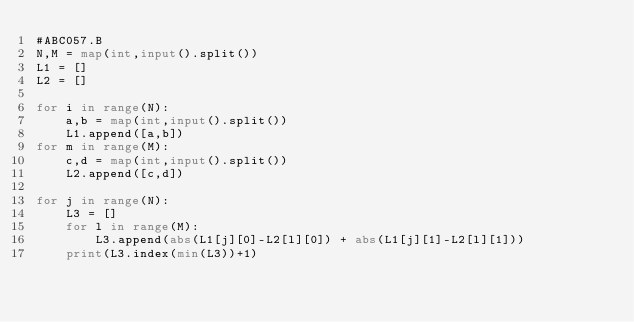Convert code to text. <code><loc_0><loc_0><loc_500><loc_500><_Python_>#ABC057.B
N,M = map(int,input().split())
L1 = []
L2 = []

for i in range(N):
    a,b = map(int,input().split())
    L1.append([a,b])
for m in range(M):
    c,d = map(int,input().split())
    L2.append([c,d])

for j in range(N):
    L3 = []
    for l in range(M):
        L3.append(abs(L1[j][0]-L2[l][0]) + abs(L1[j][1]-L2[l][1]))
    print(L3.index(min(L3))+1)</code> 